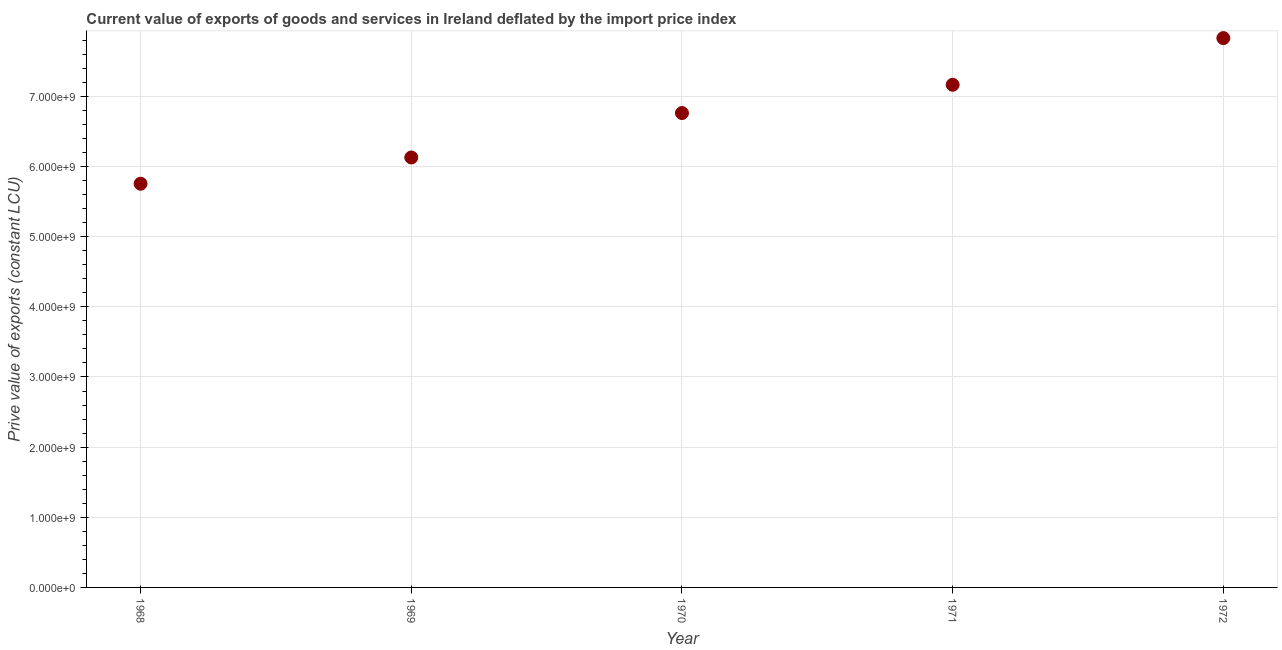What is the price value of exports in 1969?
Offer a terse response. 6.13e+09. Across all years, what is the maximum price value of exports?
Your response must be concise. 7.83e+09. Across all years, what is the minimum price value of exports?
Your answer should be compact. 5.75e+09. In which year was the price value of exports maximum?
Your response must be concise. 1972. In which year was the price value of exports minimum?
Make the answer very short. 1968. What is the sum of the price value of exports?
Offer a terse response. 3.36e+1. What is the difference between the price value of exports in 1970 and 1972?
Ensure brevity in your answer.  -1.07e+09. What is the average price value of exports per year?
Your answer should be very brief. 6.73e+09. What is the median price value of exports?
Keep it short and to the point. 6.76e+09. Do a majority of the years between 1970 and 1971 (inclusive) have price value of exports greater than 7200000000 LCU?
Keep it short and to the point. No. What is the ratio of the price value of exports in 1969 to that in 1971?
Offer a terse response. 0.86. Is the price value of exports in 1969 less than that in 1971?
Give a very brief answer. Yes. What is the difference between the highest and the second highest price value of exports?
Give a very brief answer. 6.65e+08. What is the difference between the highest and the lowest price value of exports?
Give a very brief answer. 2.08e+09. How many dotlines are there?
Make the answer very short. 1. Are the values on the major ticks of Y-axis written in scientific E-notation?
Your answer should be compact. Yes. Does the graph contain any zero values?
Your answer should be compact. No. Does the graph contain grids?
Keep it short and to the point. Yes. What is the title of the graph?
Your answer should be very brief. Current value of exports of goods and services in Ireland deflated by the import price index. What is the label or title of the X-axis?
Give a very brief answer. Year. What is the label or title of the Y-axis?
Your response must be concise. Prive value of exports (constant LCU). What is the Prive value of exports (constant LCU) in 1968?
Offer a terse response. 5.75e+09. What is the Prive value of exports (constant LCU) in 1969?
Your response must be concise. 6.13e+09. What is the Prive value of exports (constant LCU) in 1970?
Give a very brief answer. 6.76e+09. What is the Prive value of exports (constant LCU) in 1971?
Your response must be concise. 7.17e+09. What is the Prive value of exports (constant LCU) in 1972?
Offer a terse response. 7.83e+09. What is the difference between the Prive value of exports (constant LCU) in 1968 and 1969?
Provide a short and direct response. -3.74e+08. What is the difference between the Prive value of exports (constant LCU) in 1968 and 1970?
Keep it short and to the point. -1.01e+09. What is the difference between the Prive value of exports (constant LCU) in 1968 and 1971?
Make the answer very short. -1.41e+09. What is the difference between the Prive value of exports (constant LCU) in 1968 and 1972?
Offer a terse response. -2.08e+09. What is the difference between the Prive value of exports (constant LCU) in 1969 and 1970?
Your answer should be very brief. -6.33e+08. What is the difference between the Prive value of exports (constant LCU) in 1969 and 1971?
Your answer should be compact. -1.04e+09. What is the difference between the Prive value of exports (constant LCU) in 1969 and 1972?
Your answer should be compact. -1.70e+09. What is the difference between the Prive value of exports (constant LCU) in 1970 and 1971?
Provide a short and direct response. -4.03e+08. What is the difference between the Prive value of exports (constant LCU) in 1970 and 1972?
Offer a terse response. -1.07e+09. What is the difference between the Prive value of exports (constant LCU) in 1971 and 1972?
Offer a terse response. -6.65e+08. What is the ratio of the Prive value of exports (constant LCU) in 1968 to that in 1969?
Give a very brief answer. 0.94. What is the ratio of the Prive value of exports (constant LCU) in 1968 to that in 1970?
Your answer should be very brief. 0.85. What is the ratio of the Prive value of exports (constant LCU) in 1968 to that in 1971?
Provide a short and direct response. 0.8. What is the ratio of the Prive value of exports (constant LCU) in 1968 to that in 1972?
Your answer should be very brief. 0.73. What is the ratio of the Prive value of exports (constant LCU) in 1969 to that in 1970?
Your answer should be very brief. 0.91. What is the ratio of the Prive value of exports (constant LCU) in 1969 to that in 1971?
Your answer should be compact. 0.85. What is the ratio of the Prive value of exports (constant LCU) in 1969 to that in 1972?
Offer a terse response. 0.78. What is the ratio of the Prive value of exports (constant LCU) in 1970 to that in 1971?
Your answer should be very brief. 0.94. What is the ratio of the Prive value of exports (constant LCU) in 1970 to that in 1972?
Give a very brief answer. 0.86. What is the ratio of the Prive value of exports (constant LCU) in 1971 to that in 1972?
Ensure brevity in your answer.  0.92. 